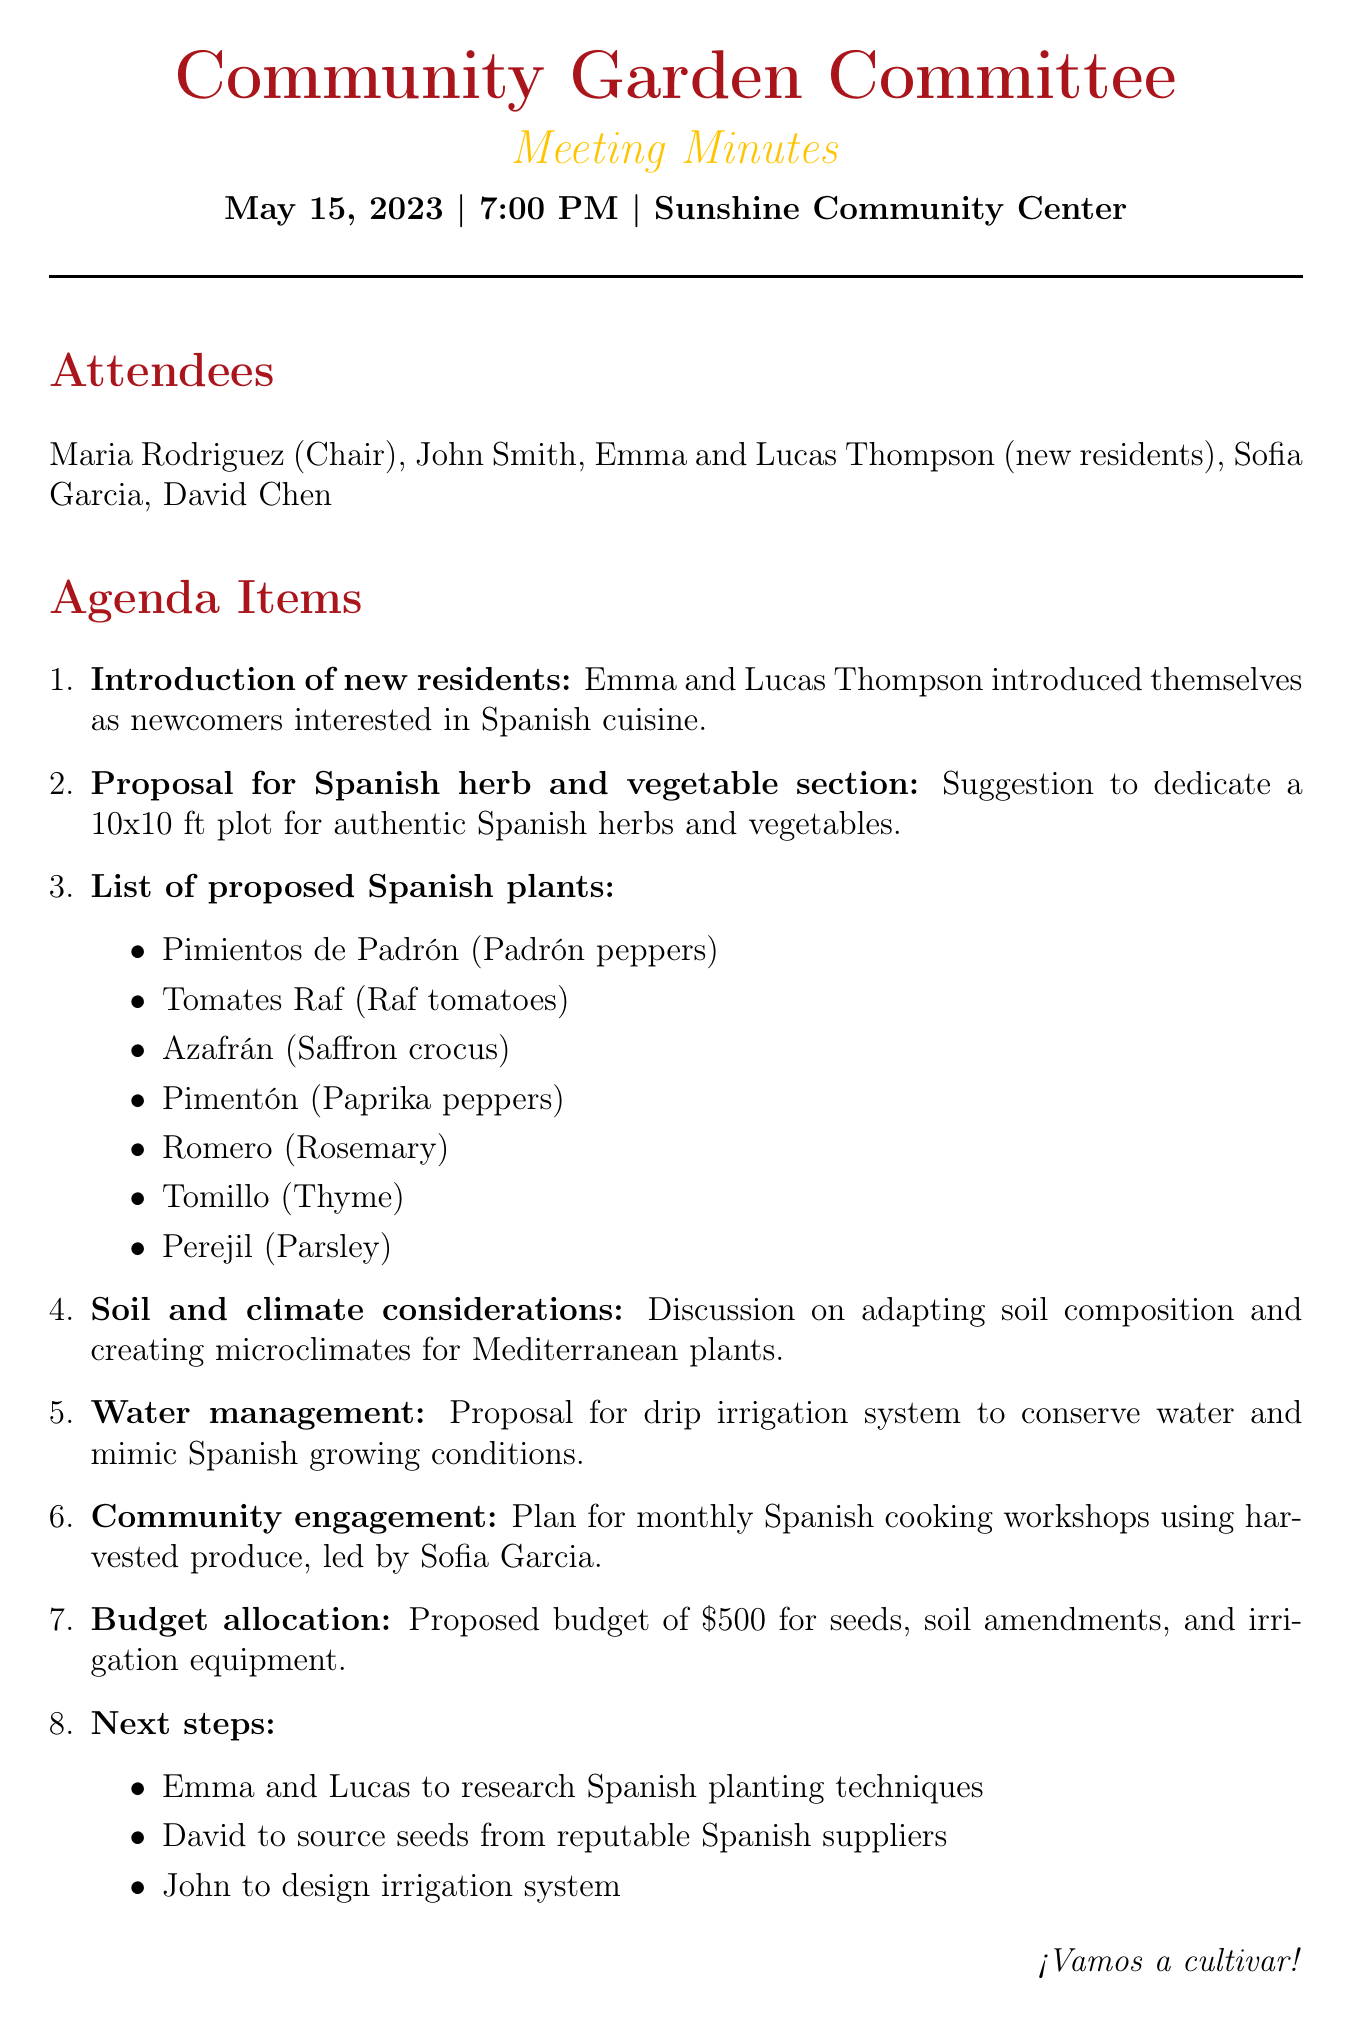What is the date of the meeting? The date of the meeting is stated at the beginning of the document as May 15, 2023.
Answer: May 15, 2023 Who introduced themselves as newcomers? The names of the newcomers are mentioned in the introduction section of the document, which lists Emma and Lucas Thompson.
Answer: Emma and Lucas Thompson What is the proposed size of the Spanish herb and vegetable plot? The document specifies the plot size for herbs and vegetables as 10x10 ft in the proposal section.
Answer: 10x10 ft Which herb is listed as “Romero” in Spanish? The document includes a list of proposed plants, where "Romero" is identified as rosemary.
Answer: Rosemary What is the proposed budget for seeds and equipment? The document mentions a proposed budget allocation of $500 for seeds, soil amendments, and irrigation equipment.
Answer: $500 What type of irrigation system was proposed? The discussion about water management includes a proposal for a drip irrigation system.
Answer: Drip irrigation system Who is leading the monthly cooking workshops? The document states that the monthly cooking workshops are to be led by Sofia Garcia.
Answer: Sofia Garcia What action is Emma and Lucas tasked with? The next steps section indicates Emma and Lucas are to research Spanish planting techniques.
Answer: Research Spanish planting techniques 